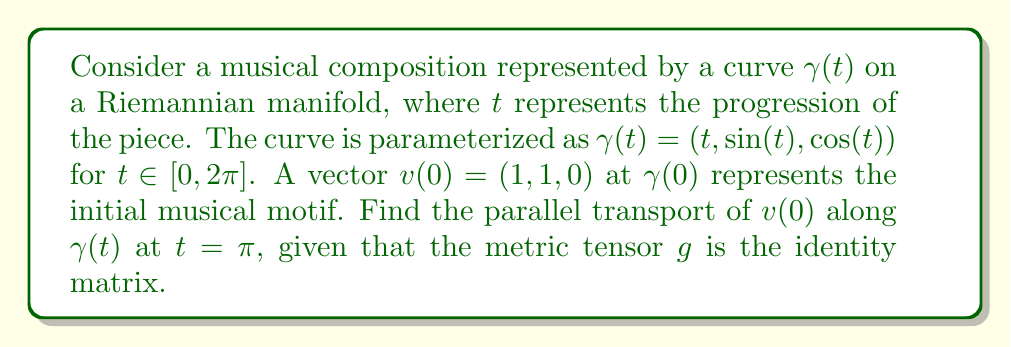Solve this math problem. To solve this problem, we'll follow these steps:

1) The parallel transport equation is given by:

   $$\frac{Dv}{dt} = \nabla_{\dot{\gamma}}v = 0$$

2) In component form, this becomes:

   $$\frac{dv^i}{dt} + \Gamma^i_{jk}v^j\dot{\gamma}^k = 0$$

   where $\Gamma^i_{jk}$ are the Christoffel symbols.

3) Given that the metric tensor is the identity matrix, all Christoffel symbols are zero. Thus, our equation simplifies to:

   $$\frac{dv^i}{dt} = 0$$

4) This means that each component of $v$ remains constant along $\gamma(t)$. Therefore, $v(t) = v(0)$ for all $t$.

5) We're given that $v(0) = (1, 1, 0)$, so $v(\pi) = (1, 1, 0)$ as well.

6) To verify, we can check that this vector is indeed perpendicular to $\dot{\gamma}(\pi)$:

   $$\dot{\gamma}(\pi) = (1, \cos(\pi), -\sin(\pi)) = (1, -1, 0)$$

   The dot product $v(\pi) \cdot \dot{\gamma}(\pi) = 1(1) + 1(-1) + 0(0) = 0$, confirming perpendicularity.

Therefore, the parallel transport of $v(0)$ along $\gamma(t)$ at $t = \pi$ is $(1, 1, 0)$.
Answer: $(1, 1, 0)$ 